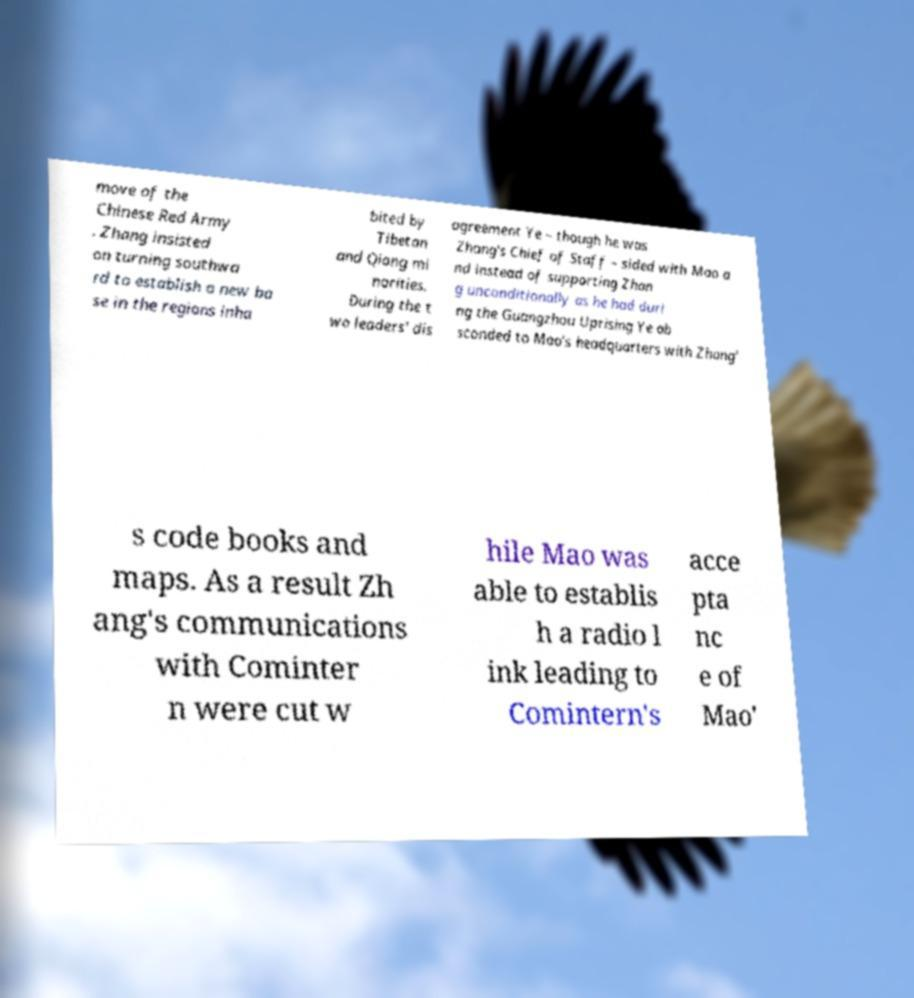Can you read and provide the text displayed in the image?This photo seems to have some interesting text. Can you extract and type it out for me? move of the Chinese Red Army . Zhang insisted on turning southwa rd to establish a new ba se in the regions inha bited by Tibetan and Qiang mi norities. During the t wo leaders' dis agreement Ye – though he was Zhang's Chief of Staff – sided with Mao a nd instead of supporting Zhan g unconditionally as he had duri ng the Guangzhou Uprising Ye ab sconded to Mao's headquarters with Zhang' s code books and maps. As a result Zh ang's communications with Cominter n were cut w hile Mao was able to establis h a radio l ink leading to Comintern's acce pta nc e of Mao' 